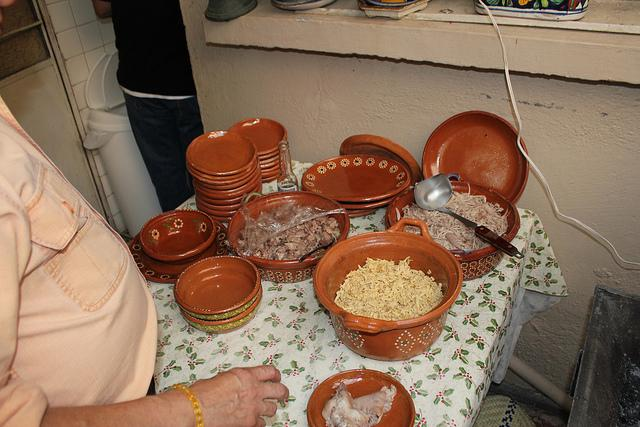Where is this food located? table 